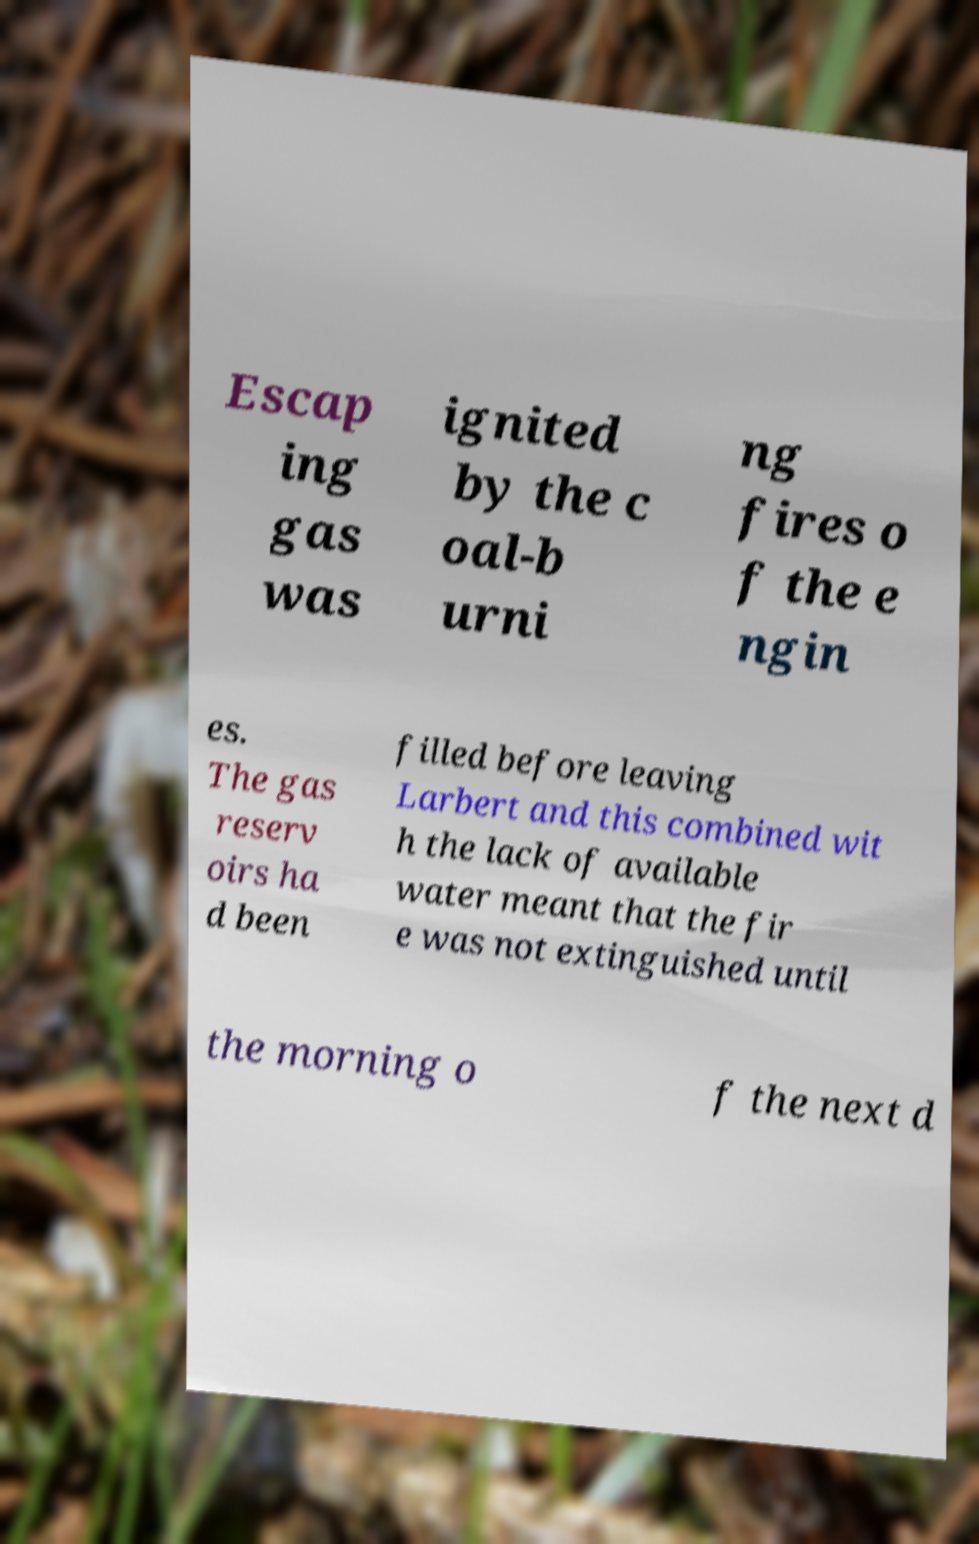What messages or text are displayed in this image? I need them in a readable, typed format. Escap ing gas was ignited by the c oal-b urni ng fires o f the e ngin es. The gas reserv oirs ha d been filled before leaving Larbert and this combined wit h the lack of available water meant that the fir e was not extinguished until the morning o f the next d 